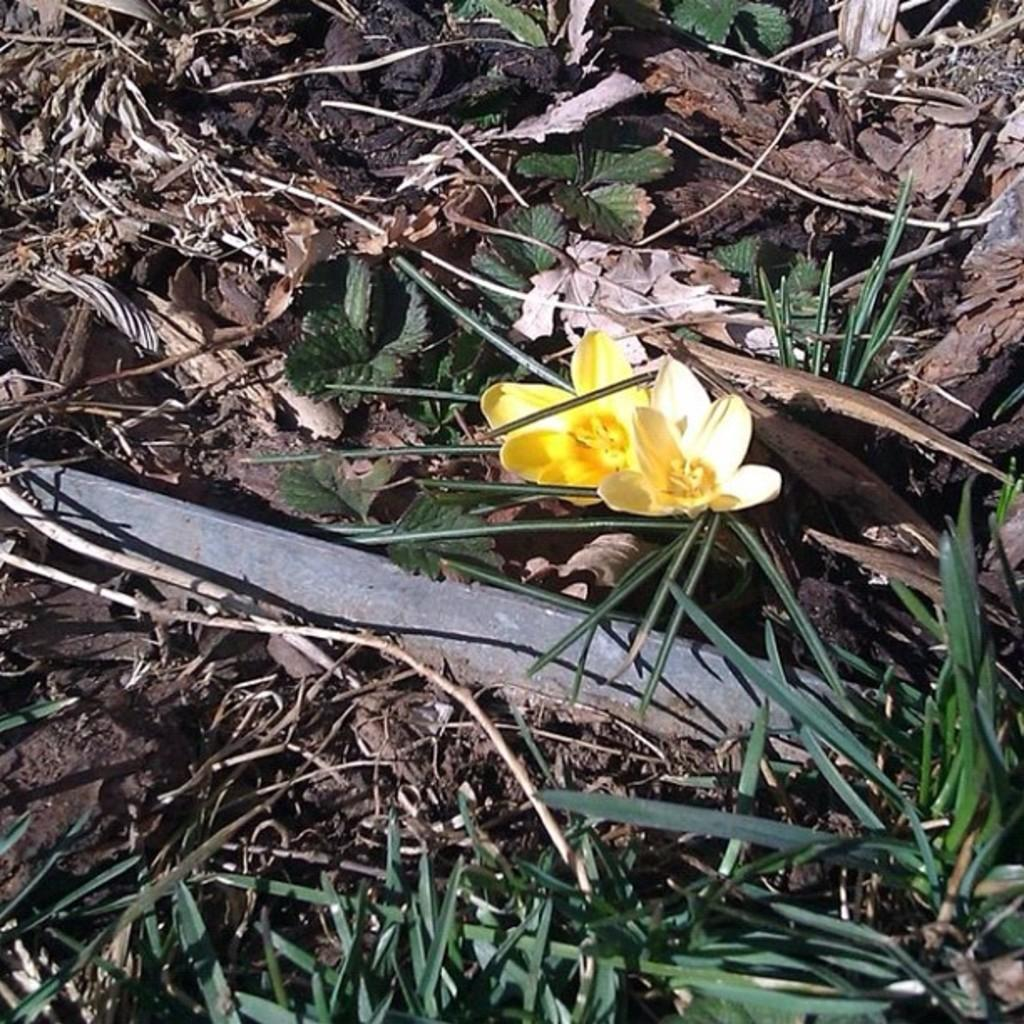How many flowers can be seen on the ground in the image? There are two flowers on the ground in the image. What else is present at the bottom of the image? There are plants at the bottom of the image. What is located beside the flowers? There are leaves beside the flowers. What type of surface is the ground covered with? The ground is covered in sand. How does the lamp illuminate the flowers in the image? There is no lamp present in the image; it only features flowers, leaves, plants, and sand. 